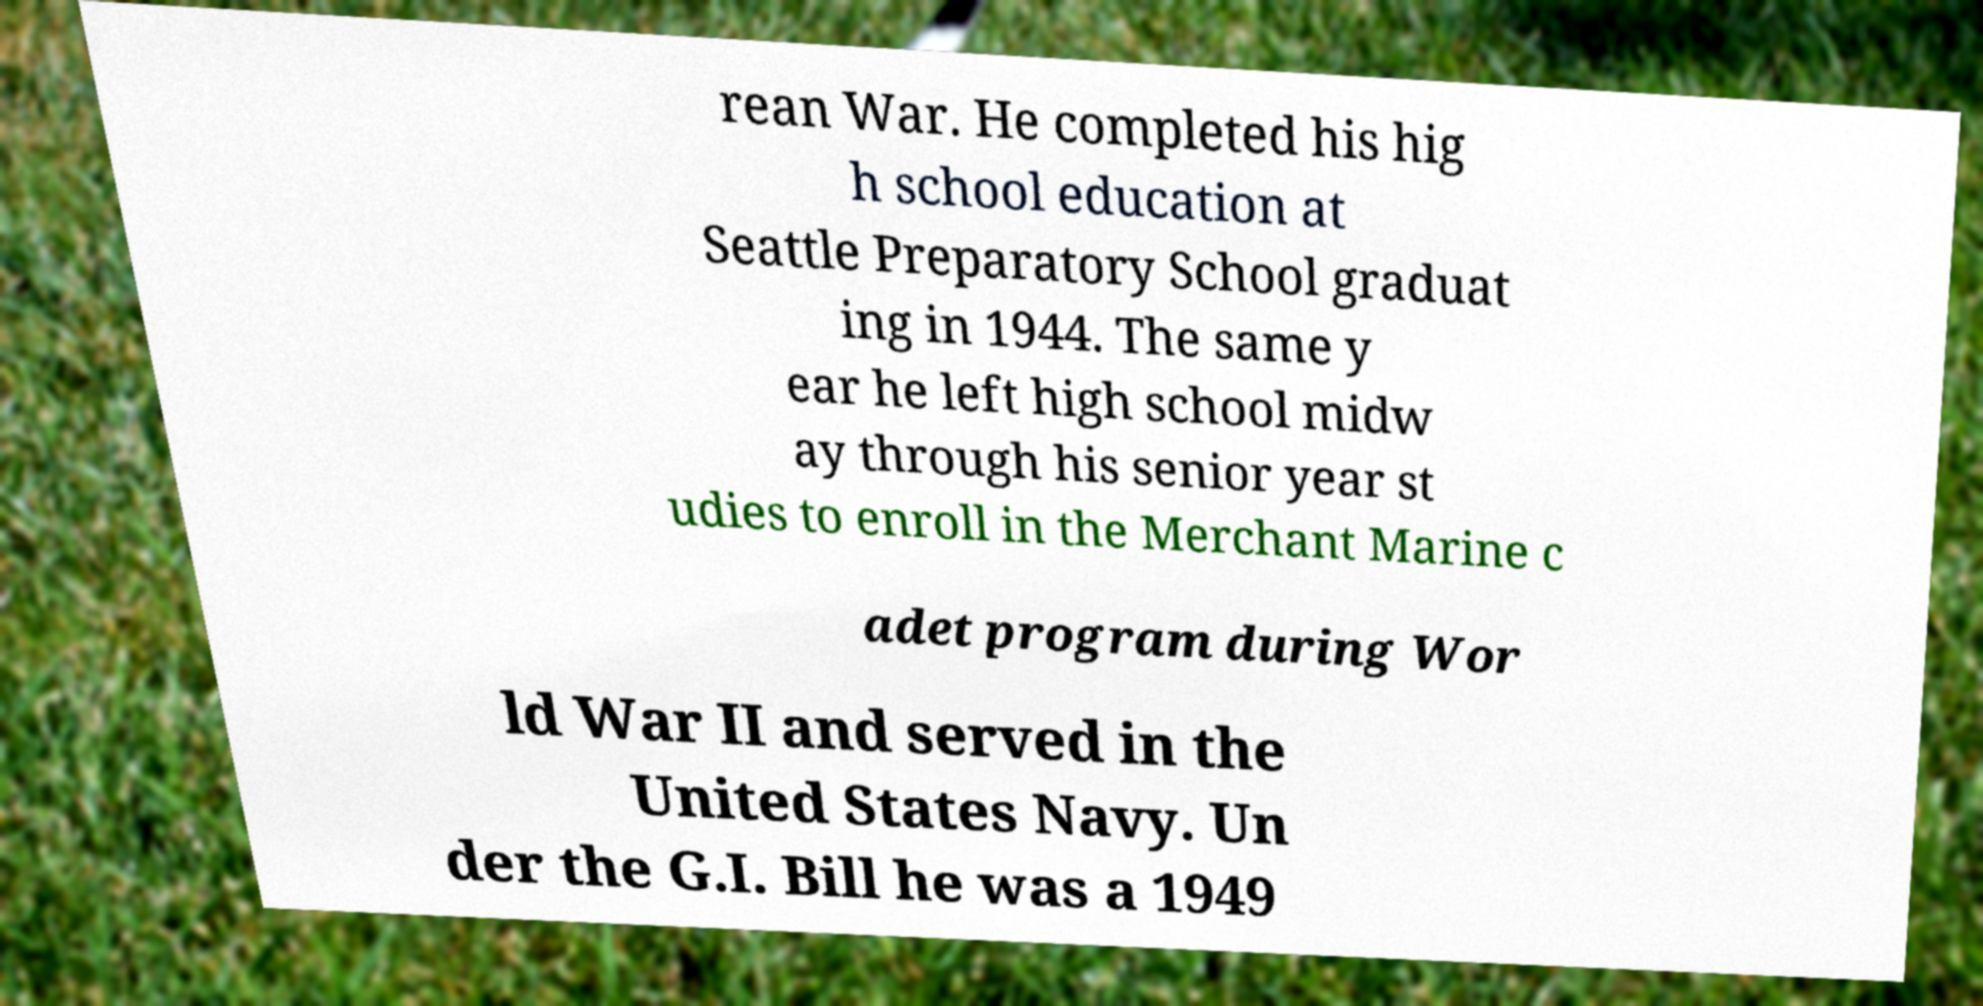Can you read and provide the text displayed in the image?This photo seems to have some interesting text. Can you extract and type it out for me? rean War. He completed his hig h school education at Seattle Preparatory School graduat ing in 1944. The same y ear he left high school midw ay through his senior year st udies to enroll in the Merchant Marine c adet program during Wor ld War II and served in the United States Navy. Un der the G.I. Bill he was a 1949 